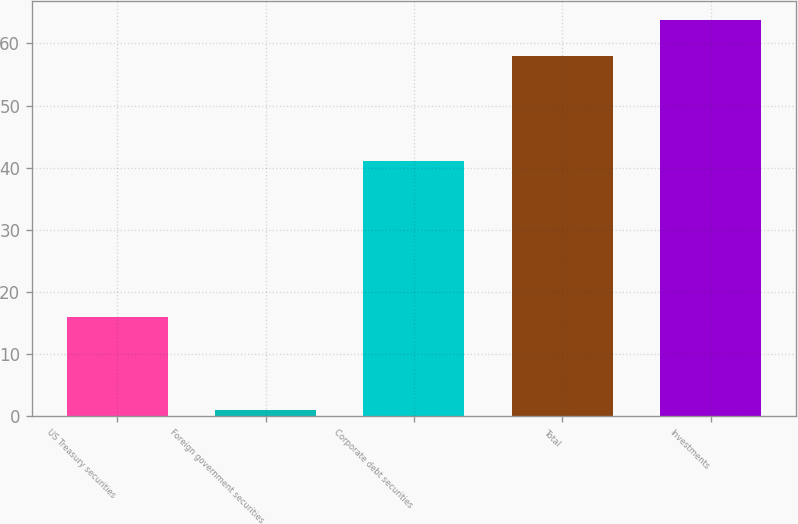<chart> <loc_0><loc_0><loc_500><loc_500><bar_chart><fcel>US Treasury securities<fcel>Foreign government securities<fcel>Corporate debt securities<fcel>Total<fcel>Investments<nl><fcel>16<fcel>1<fcel>41<fcel>58<fcel>63.7<nl></chart> 